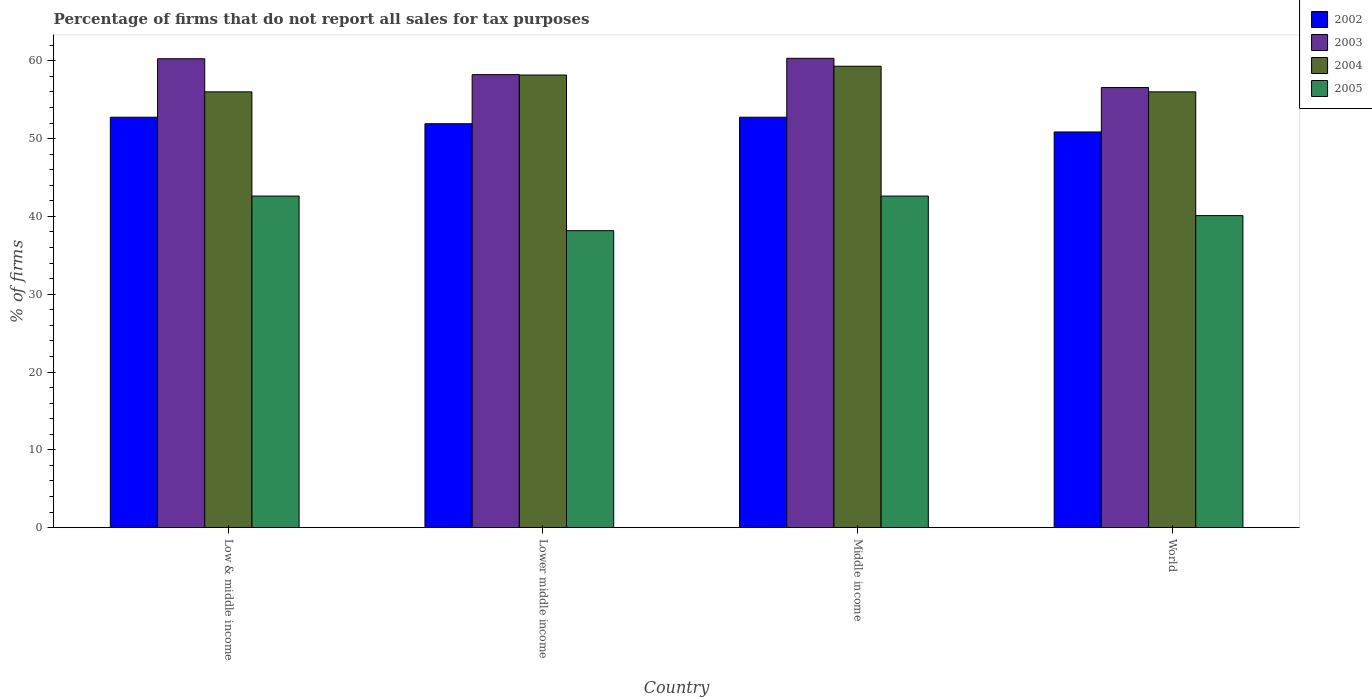How many different coloured bars are there?
Offer a terse response. 4. How many groups of bars are there?
Keep it short and to the point. 4. Are the number of bars on each tick of the X-axis equal?
Offer a very short reply. Yes. What is the label of the 4th group of bars from the left?
Provide a short and direct response. World. In how many cases, is the number of bars for a given country not equal to the number of legend labels?
Make the answer very short. 0. What is the percentage of firms that do not report all sales for tax purposes in 2004 in Lower middle income?
Provide a succinct answer. 58.16. Across all countries, what is the maximum percentage of firms that do not report all sales for tax purposes in 2002?
Your answer should be very brief. 52.75. Across all countries, what is the minimum percentage of firms that do not report all sales for tax purposes in 2005?
Provide a short and direct response. 38.16. What is the total percentage of firms that do not report all sales for tax purposes in 2005 in the graph?
Provide a short and direct response. 163.48. What is the difference between the percentage of firms that do not report all sales for tax purposes in 2004 in Lower middle income and that in Middle income?
Provide a short and direct response. -1.13. What is the difference between the percentage of firms that do not report all sales for tax purposes in 2004 in World and the percentage of firms that do not report all sales for tax purposes in 2003 in Lower middle income?
Provide a short and direct response. -2.21. What is the average percentage of firms that do not report all sales for tax purposes in 2004 per country?
Offer a very short reply. 57.37. What is the difference between the percentage of firms that do not report all sales for tax purposes of/in 2002 and percentage of firms that do not report all sales for tax purposes of/in 2005 in Middle income?
Offer a terse response. 10.13. In how many countries, is the percentage of firms that do not report all sales for tax purposes in 2005 greater than 48 %?
Offer a very short reply. 0. What is the ratio of the percentage of firms that do not report all sales for tax purposes in 2002 in Middle income to that in World?
Ensure brevity in your answer.  1.04. Is the percentage of firms that do not report all sales for tax purposes in 2005 in Lower middle income less than that in Middle income?
Provide a short and direct response. Yes. Is the difference between the percentage of firms that do not report all sales for tax purposes in 2002 in Middle income and World greater than the difference between the percentage of firms that do not report all sales for tax purposes in 2005 in Middle income and World?
Your answer should be compact. No. What is the difference between the highest and the second highest percentage of firms that do not report all sales for tax purposes in 2004?
Offer a terse response. -2.16. What is the difference between the highest and the lowest percentage of firms that do not report all sales for tax purposes in 2005?
Provide a short and direct response. 4.45. Is the sum of the percentage of firms that do not report all sales for tax purposes in 2004 in Low & middle income and Middle income greater than the maximum percentage of firms that do not report all sales for tax purposes in 2002 across all countries?
Your answer should be very brief. Yes. Is it the case that in every country, the sum of the percentage of firms that do not report all sales for tax purposes in 2002 and percentage of firms that do not report all sales for tax purposes in 2005 is greater than the sum of percentage of firms that do not report all sales for tax purposes in 2004 and percentage of firms that do not report all sales for tax purposes in 2003?
Your response must be concise. Yes. What does the 1st bar from the left in Lower middle income represents?
Give a very brief answer. 2002. What does the 3rd bar from the right in Lower middle income represents?
Provide a succinct answer. 2003. Is it the case that in every country, the sum of the percentage of firms that do not report all sales for tax purposes in 2004 and percentage of firms that do not report all sales for tax purposes in 2005 is greater than the percentage of firms that do not report all sales for tax purposes in 2003?
Offer a terse response. Yes. How many bars are there?
Your response must be concise. 16. How many countries are there in the graph?
Keep it short and to the point. 4. Are the values on the major ticks of Y-axis written in scientific E-notation?
Offer a very short reply. No. What is the title of the graph?
Keep it short and to the point. Percentage of firms that do not report all sales for tax purposes. What is the label or title of the Y-axis?
Make the answer very short. % of firms. What is the % of firms in 2002 in Low & middle income?
Make the answer very short. 52.75. What is the % of firms of 2003 in Low & middle income?
Keep it short and to the point. 60.26. What is the % of firms in 2004 in Low & middle income?
Keep it short and to the point. 56.01. What is the % of firms of 2005 in Low & middle income?
Offer a terse response. 42.61. What is the % of firms of 2002 in Lower middle income?
Make the answer very short. 51.91. What is the % of firms in 2003 in Lower middle income?
Make the answer very short. 58.22. What is the % of firms of 2004 in Lower middle income?
Your answer should be very brief. 58.16. What is the % of firms in 2005 in Lower middle income?
Ensure brevity in your answer.  38.16. What is the % of firms of 2002 in Middle income?
Provide a succinct answer. 52.75. What is the % of firms in 2003 in Middle income?
Your response must be concise. 60.31. What is the % of firms of 2004 in Middle income?
Your answer should be compact. 59.3. What is the % of firms in 2005 in Middle income?
Provide a succinct answer. 42.61. What is the % of firms of 2002 in World?
Provide a succinct answer. 50.85. What is the % of firms in 2003 in World?
Ensure brevity in your answer.  56.56. What is the % of firms of 2004 in World?
Ensure brevity in your answer.  56.01. What is the % of firms in 2005 in World?
Your response must be concise. 40.1. Across all countries, what is the maximum % of firms in 2002?
Keep it short and to the point. 52.75. Across all countries, what is the maximum % of firms in 2003?
Ensure brevity in your answer.  60.31. Across all countries, what is the maximum % of firms in 2004?
Ensure brevity in your answer.  59.3. Across all countries, what is the maximum % of firms of 2005?
Ensure brevity in your answer.  42.61. Across all countries, what is the minimum % of firms in 2002?
Offer a very short reply. 50.85. Across all countries, what is the minimum % of firms in 2003?
Your response must be concise. 56.56. Across all countries, what is the minimum % of firms in 2004?
Offer a terse response. 56.01. Across all countries, what is the minimum % of firms in 2005?
Provide a succinct answer. 38.16. What is the total % of firms of 2002 in the graph?
Your answer should be compact. 208.25. What is the total % of firms of 2003 in the graph?
Make the answer very short. 235.35. What is the total % of firms of 2004 in the graph?
Provide a short and direct response. 229.47. What is the total % of firms in 2005 in the graph?
Ensure brevity in your answer.  163.48. What is the difference between the % of firms in 2002 in Low & middle income and that in Lower middle income?
Provide a short and direct response. 0.84. What is the difference between the % of firms in 2003 in Low & middle income and that in Lower middle income?
Offer a terse response. 2.04. What is the difference between the % of firms of 2004 in Low & middle income and that in Lower middle income?
Provide a short and direct response. -2.16. What is the difference between the % of firms in 2005 in Low & middle income and that in Lower middle income?
Give a very brief answer. 4.45. What is the difference between the % of firms of 2002 in Low & middle income and that in Middle income?
Give a very brief answer. 0. What is the difference between the % of firms in 2003 in Low & middle income and that in Middle income?
Make the answer very short. -0.05. What is the difference between the % of firms of 2004 in Low & middle income and that in Middle income?
Offer a very short reply. -3.29. What is the difference between the % of firms in 2002 in Low & middle income and that in World?
Offer a terse response. 1.89. What is the difference between the % of firms in 2005 in Low & middle income and that in World?
Offer a terse response. 2.51. What is the difference between the % of firms of 2002 in Lower middle income and that in Middle income?
Your response must be concise. -0.84. What is the difference between the % of firms of 2003 in Lower middle income and that in Middle income?
Offer a very short reply. -2.09. What is the difference between the % of firms in 2004 in Lower middle income and that in Middle income?
Give a very brief answer. -1.13. What is the difference between the % of firms of 2005 in Lower middle income and that in Middle income?
Offer a terse response. -4.45. What is the difference between the % of firms of 2002 in Lower middle income and that in World?
Make the answer very short. 1.06. What is the difference between the % of firms of 2003 in Lower middle income and that in World?
Ensure brevity in your answer.  1.66. What is the difference between the % of firms of 2004 in Lower middle income and that in World?
Provide a succinct answer. 2.16. What is the difference between the % of firms of 2005 in Lower middle income and that in World?
Provide a succinct answer. -1.94. What is the difference between the % of firms of 2002 in Middle income and that in World?
Give a very brief answer. 1.89. What is the difference between the % of firms of 2003 in Middle income and that in World?
Offer a terse response. 3.75. What is the difference between the % of firms in 2004 in Middle income and that in World?
Offer a very short reply. 3.29. What is the difference between the % of firms of 2005 in Middle income and that in World?
Make the answer very short. 2.51. What is the difference between the % of firms of 2002 in Low & middle income and the % of firms of 2003 in Lower middle income?
Offer a very short reply. -5.47. What is the difference between the % of firms of 2002 in Low & middle income and the % of firms of 2004 in Lower middle income?
Offer a terse response. -5.42. What is the difference between the % of firms of 2002 in Low & middle income and the % of firms of 2005 in Lower middle income?
Provide a short and direct response. 14.58. What is the difference between the % of firms of 2003 in Low & middle income and the % of firms of 2004 in Lower middle income?
Your response must be concise. 2.1. What is the difference between the % of firms in 2003 in Low & middle income and the % of firms in 2005 in Lower middle income?
Keep it short and to the point. 22.1. What is the difference between the % of firms in 2004 in Low & middle income and the % of firms in 2005 in Lower middle income?
Your response must be concise. 17.84. What is the difference between the % of firms in 2002 in Low & middle income and the % of firms in 2003 in Middle income?
Provide a short and direct response. -7.57. What is the difference between the % of firms of 2002 in Low & middle income and the % of firms of 2004 in Middle income?
Ensure brevity in your answer.  -6.55. What is the difference between the % of firms of 2002 in Low & middle income and the % of firms of 2005 in Middle income?
Give a very brief answer. 10.13. What is the difference between the % of firms of 2003 in Low & middle income and the % of firms of 2005 in Middle income?
Your response must be concise. 17.65. What is the difference between the % of firms in 2004 in Low & middle income and the % of firms in 2005 in Middle income?
Give a very brief answer. 13.39. What is the difference between the % of firms of 2002 in Low & middle income and the % of firms of 2003 in World?
Keep it short and to the point. -3.81. What is the difference between the % of firms in 2002 in Low & middle income and the % of firms in 2004 in World?
Offer a very short reply. -3.26. What is the difference between the % of firms in 2002 in Low & middle income and the % of firms in 2005 in World?
Offer a very short reply. 12.65. What is the difference between the % of firms in 2003 in Low & middle income and the % of firms in 2004 in World?
Your answer should be compact. 4.25. What is the difference between the % of firms of 2003 in Low & middle income and the % of firms of 2005 in World?
Keep it short and to the point. 20.16. What is the difference between the % of firms in 2004 in Low & middle income and the % of firms in 2005 in World?
Provide a succinct answer. 15.91. What is the difference between the % of firms in 2002 in Lower middle income and the % of firms in 2003 in Middle income?
Your answer should be compact. -8.4. What is the difference between the % of firms of 2002 in Lower middle income and the % of firms of 2004 in Middle income?
Keep it short and to the point. -7.39. What is the difference between the % of firms in 2002 in Lower middle income and the % of firms in 2005 in Middle income?
Your answer should be very brief. 9.3. What is the difference between the % of firms in 2003 in Lower middle income and the % of firms in 2004 in Middle income?
Make the answer very short. -1.08. What is the difference between the % of firms of 2003 in Lower middle income and the % of firms of 2005 in Middle income?
Offer a very short reply. 15.61. What is the difference between the % of firms of 2004 in Lower middle income and the % of firms of 2005 in Middle income?
Give a very brief answer. 15.55. What is the difference between the % of firms in 2002 in Lower middle income and the % of firms in 2003 in World?
Make the answer very short. -4.65. What is the difference between the % of firms in 2002 in Lower middle income and the % of firms in 2004 in World?
Give a very brief answer. -4.1. What is the difference between the % of firms of 2002 in Lower middle income and the % of firms of 2005 in World?
Offer a very short reply. 11.81. What is the difference between the % of firms of 2003 in Lower middle income and the % of firms of 2004 in World?
Provide a short and direct response. 2.21. What is the difference between the % of firms of 2003 in Lower middle income and the % of firms of 2005 in World?
Offer a terse response. 18.12. What is the difference between the % of firms in 2004 in Lower middle income and the % of firms in 2005 in World?
Your answer should be very brief. 18.07. What is the difference between the % of firms of 2002 in Middle income and the % of firms of 2003 in World?
Keep it short and to the point. -3.81. What is the difference between the % of firms in 2002 in Middle income and the % of firms in 2004 in World?
Make the answer very short. -3.26. What is the difference between the % of firms of 2002 in Middle income and the % of firms of 2005 in World?
Offer a very short reply. 12.65. What is the difference between the % of firms in 2003 in Middle income and the % of firms in 2004 in World?
Your answer should be very brief. 4.31. What is the difference between the % of firms of 2003 in Middle income and the % of firms of 2005 in World?
Make the answer very short. 20.21. What is the difference between the % of firms in 2004 in Middle income and the % of firms in 2005 in World?
Keep it short and to the point. 19.2. What is the average % of firms in 2002 per country?
Give a very brief answer. 52.06. What is the average % of firms in 2003 per country?
Keep it short and to the point. 58.84. What is the average % of firms of 2004 per country?
Your response must be concise. 57.37. What is the average % of firms of 2005 per country?
Offer a very short reply. 40.87. What is the difference between the % of firms in 2002 and % of firms in 2003 in Low & middle income?
Offer a terse response. -7.51. What is the difference between the % of firms in 2002 and % of firms in 2004 in Low & middle income?
Your answer should be compact. -3.26. What is the difference between the % of firms in 2002 and % of firms in 2005 in Low & middle income?
Provide a short and direct response. 10.13. What is the difference between the % of firms in 2003 and % of firms in 2004 in Low & middle income?
Keep it short and to the point. 4.25. What is the difference between the % of firms of 2003 and % of firms of 2005 in Low & middle income?
Your response must be concise. 17.65. What is the difference between the % of firms of 2004 and % of firms of 2005 in Low & middle income?
Your response must be concise. 13.39. What is the difference between the % of firms of 2002 and % of firms of 2003 in Lower middle income?
Provide a short and direct response. -6.31. What is the difference between the % of firms in 2002 and % of firms in 2004 in Lower middle income?
Provide a short and direct response. -6.26. What is the difference between the % of firms in 2002 and % of firms in 2005 in Lower middle income?
Your answer should be very brief. 13.75. What is the difference between the % of firms of 2003 and % of firms of 2004 in Lower middle income?
Provide a succinct answer. 0.05. What is the difference between the % of firms in 2003 and % of firms in 2005 in Lower middle income?
Your answer should be very brief. 20.06. What is the difference between the % of firms of 2004 and % of firms of 2005 in Lower middle income?
Provide a succinct answer. 20. What is the difference between the % of firms of 2002 and % of firms of 2003 in Middle income?
Offer a terse response. -7.57. What is the difference between the % of firms in 2002 and % of firms in 2004 in Middle income?
Your response must be concise. -6.55. What is the difference between the % of firms in 2002 and % of firms in 2005 in Middle income?
Provide a succinct answer. 10.13. What is the difference between the % of firms in 2003 and % of firms in 2004 in Middle income?
Ensure brevity in your answer.  1.02. What is the difference between the % of firms of 2003 and % of firms of 2005 in Middle income?
Your response must be concise. 17.7. What is the difference between the % of firms in 2004 and % of firms in 2005 in Middle income?
Ensure brevity in your answer.  16.69. What is the difference between the % of firms in 2002 and % of firms in 2003 in World?
Offer a terse response. -5.71. What is the difference between the % of firms in 2002 and % of firms in 2004 in World?
Offer a terse response. -5.15. What is the difference between the % of firms of 2002 and % of firms of 2005 in World?
Give a very brief answer. 10.75. What is the difference between the % of firms in 2003 and % of firms in 2004 in World?
Provide a succinct answer. 0.56. What is the difference between the % of firms of 2003 and % of firms of 2005 in World?
Your answer should be compact. 16.46. What is the difference between the % of firms in 2004 and % of firms in 2005 in World?
Your response must be concise. 15.91. What is the ratio of the % of firms in 2002 in Low & middle income to that in Lower middle income?
Provide a succinct answer. 1.02. What is the ratio of the % of firms of 2003 in Low & middle income to that in Lower middle income?
Your answer should be compact. 1.04. What is the ratio of the % of firms in 2004 in Low & middle income to that in Lower middle income?
Provide a short and direct response. 0.96. What is the ratio of the % of firms in 2005 in Low & middle income to that in Lower middle income?
Give a very brief answer. 1.12. What is the ratio of the % of firms in 2004 in Low & middle income to that in Middle income?
Make the answer very short. 0.94. What is the ratio of the % of firms of 2005 in Low & middle income to that in Middle income?
Your answer should be very brief. 1. What is the ratio of the % of firms in 2002 in Low & middle income to that in World?
Keep it short and to the point. 1.04. What is the ratio of the % of firms in 2003 in Low & middle income to that in World?
Keep it short and to the point. 1.07. What is the ratio of the % of firms in 2005 in Low & middle income to that in World?
Ensure brevity in your answer.  1.06. What is the ratio of the % of firms in 2002 in Lower middle income to that in Middle income?
Make the answer very short. 0.98. What is the ratio of the % of firms in 2003 in Lower middle income to that in Middle income?
Provide a succinct answer. 0.97. What is the ratio of the % of firms in 2004 in Lower middle income to that in Middle income?
Give a very brief answer. 0.98. What is the ratio of the % of firms of 2005 in Lower middle income to that in Middle income?
Offer a terse response. 0.9. What is the ratio of the % of firms in 2002 in Lower middle income to that in World?
Give a very brief answer. 1.02. What is the ratio of the % of firms in 2003 in Lower middle income to that in World?
Your response must be concise. 1.03. What is the ratio of the % of firms of 2004 in Lower middle income to that in World?
Make the answer very short. 1.04. What is the ratio of the % of firms of 2005 in Lower middle income to that in World?
Your response must be concise. 0.95. What is the ratio of the % of firms in 2002 in Middle income to that in World?
Your answer should be compact. 1.04. What is the ratio of the % of firms of 2003 in Middle income to that in World?
Make the answer very short. 1.07. What is the ratio of the % of firms of 2004 in Middle income to that in World?
Your answer should be compact. 1.06. What is the ratio of the % of firms of 2005 in Middle income to that in World?
Your response must be concise. 1.06. What is the difference between the highest and the second highest % of firms in 2003?
Keep it short and to the point. 0.05. What is the difference between the highest and the second highest % of firms of 2004?
Keep it short and to the point. 1.13. What is the difference between the highest and the lowest % of firms in 2002?
Provide a short and direct response. 1.89. What is the difference between the highest and the lowest % of firms of 2003?
Your answer should be compact. 3.75. What is the difference between the highest and the lowest % of firms in 2004?
Your answer should be compact. 3.29. What is the difference between the highest and the lowest % of firms in 2005?
Your answer should be compact. 4.45. 